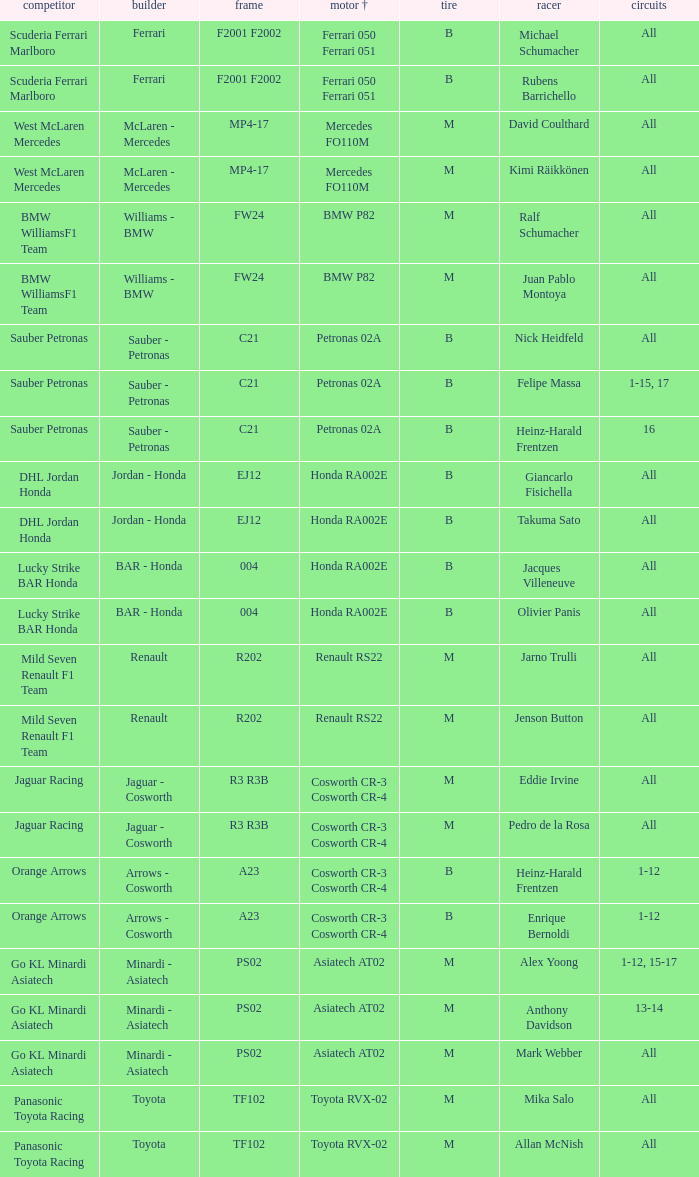Who is the operator when the motor is mercedes fo110m? David Coulthard, Kimi Räikkönen. 